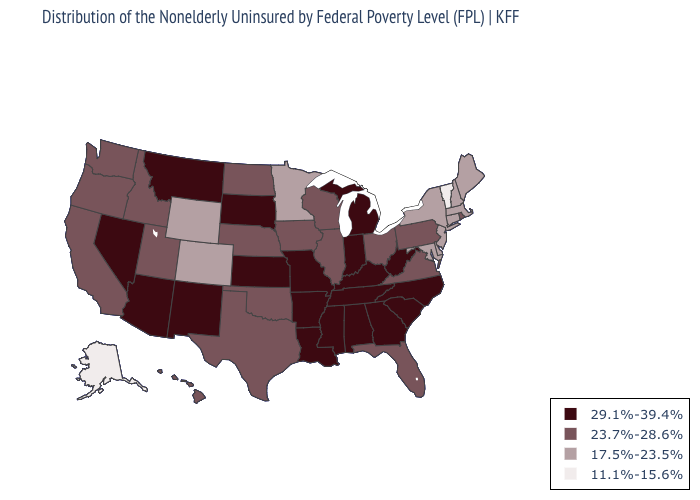Name the states that have a value in the range 23.7%-28.6%?
Short answer required. California, Florida, Hawaii, Idaho, Illinois, Iowa, Nebraska, North Dakota, Ohio, Oklahoma, Oregon, Pennsylvania, Rhode Island, Texas, Utah, Virginia, Washington, Wisconsin. Is the legend a continuous bar?
Give a very brief answer. No. Among the states that border West Virginia , does Kentucky have the lowest value?
Write a very short answer. No. Does Kansas have the lowest value in the MidWest?
Short answer required. No. Name the states that have a value in the range 17.5%-23.5%?
Write a very short answer. Colorado, Connecticut, Delaware, Maine, Maryland, Massachusetts, Minnesota, New Hampshire, New Jersey, New York, Wyoming. How many symbols are there in the legend?
Answer briefly. 4. Which states hav the highest value in the Northeast?
Keep it brief. Pennsylvania, Rhode Island. Name the states that have a value in the range 29.1%-39.4%?
Quick response, please. Alabama, Arizona, Arkansas, Georgia, Indiana, Kansas, Kentucky, Louisiana, Michigan, Mississippi, Missouri, Montana, Nevada, New Mexico, North Carolina, South Carolina, South Dakota, Tennessee, West Virginia. What is the value of New York?
Answer briefly. 17.5%-23.5%. Which states hav the highest value in the South?
Keep it brief. Alabama, Arkansas, Georgia, Kentucky, Louisiana, Mississippi, North Carolina, South Carolina, Tennessee, West Virginia. What is the highest value in the MidWest ?
Short answer required. 29.1%-39.4%. Among the states that border New Mexico , does Arizona have the highest value?
Keep it brief. Yes. Which states hav the highest value in the Northeast?
Answer briefly. Pennsylvania, Rhode Island. Does the map have missing data?
Give a very brief answer. No. What is the value of Rhode Island?
Concise answer only. 23.7%-28.6%. 